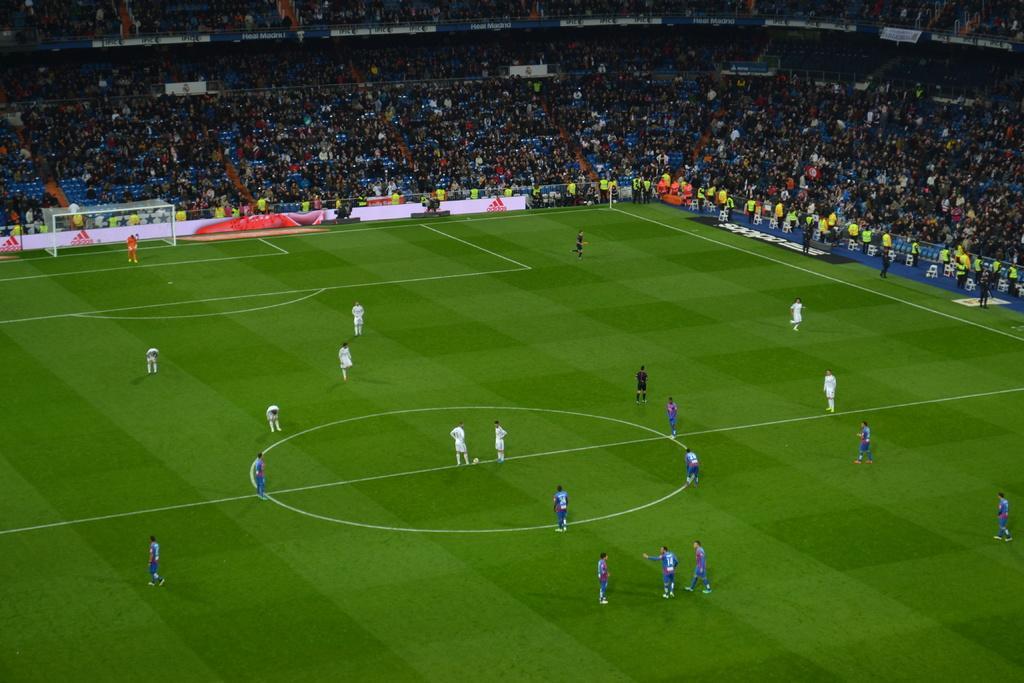In one or two sentences, can you explain what this image depicts? In the center of the image, we can see people on the ground and there is a ball. In the background, there are poles and we can see a fence, a shed, some objects and there is crowd. 